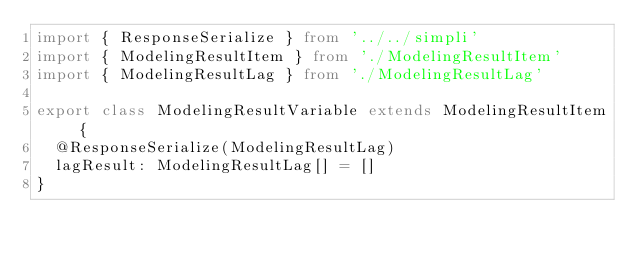<code> <loc_0><loc_0><loc_500><loc_500><_TypeScript_>import { ResponseSerialize } from '../../simpli'
import { ModelingResultItem } from './ModelingResultItem'
import { ModelingResultLag } from './ModelingResultLag'

export class ModelingResultVariable extends ModelingResultItem {
  @ResponseSerialize(ModelingResultLag)
  lagResult: ModelingResultLag[] = []
}
</code> 